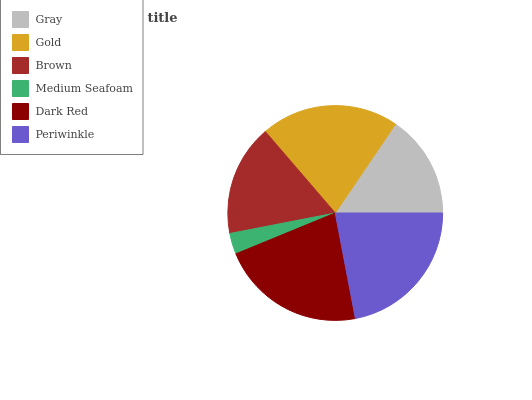Is Medium Seafoam the minimum?
Answer yes or no. Yes. Is Periwinkle the maximum?
Answer yes or no. Yes. Is Gold the minimum?
Answer yes or no. No. Is Gold the maximum?
Answer yes or no. No. Is Gold greater than Gray?
Answer yes or no. Yes. Is Gray less than Gold?
Answer yes or no. Yes. Is Gray greater than Gold?
Answer yes or no. No. Is Gold less than Gray?
Answer yes or no. No. Is Gold the high median?
Answer yes or no. Yes. Is Brown the low median?
Answer yes or no. Yes. Is Medium Seafoam the high median?
Answer yes or no. No. Is Gray the low median?
Answer yes or no. No. 